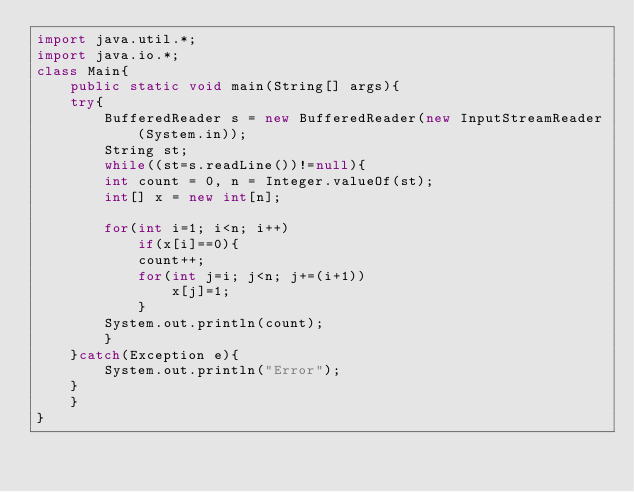Convert code to text. <code><loc_0><loc_0><loc_500><loc_500><_Java_>import java.util.*;
import java.io.*;
class Main{
    public static void main(String[] args){
	try{
	    BufferedReader s = new BufferedReader(new InputStreamReader(System.in));
	    String st;
	    while((st=s.readLine())!=null){
		int count = 0, n = Integer.valueOf(st);
		int[] x = new int[n];
		
		for(int i=1; i<n; i++)
		    if(x[i]==0){
			count++;
			for(int j=i; j<n; j+=(i+1))
			    x[j]=1;
		    }
		System.out.println(count);
	    }
	}catch(Exception e){
	    System.out.println("Error");
	}
    }
}</code> 